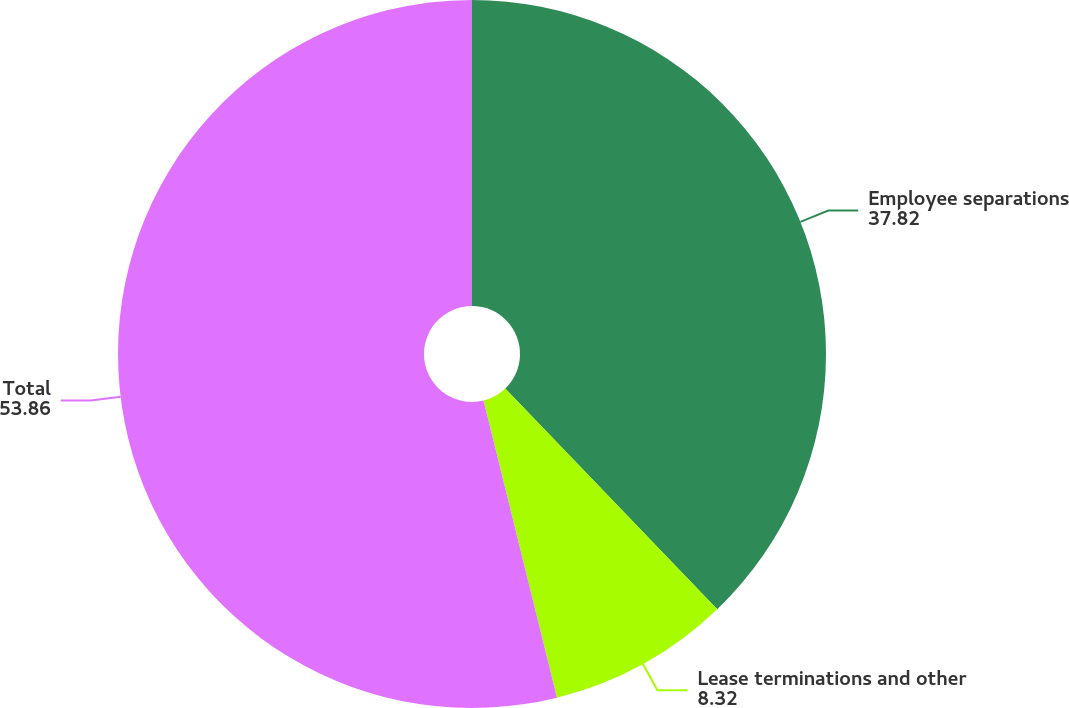<chart> <loc_0><loc_0><loc_500><loc_500><pie_chart><fcel>Employee separations<fcel>Lease terminations and other<fcel>Total<nl><fcel>37.82%<fcel>8.32%<fcel>53.86%<nl></chart> 